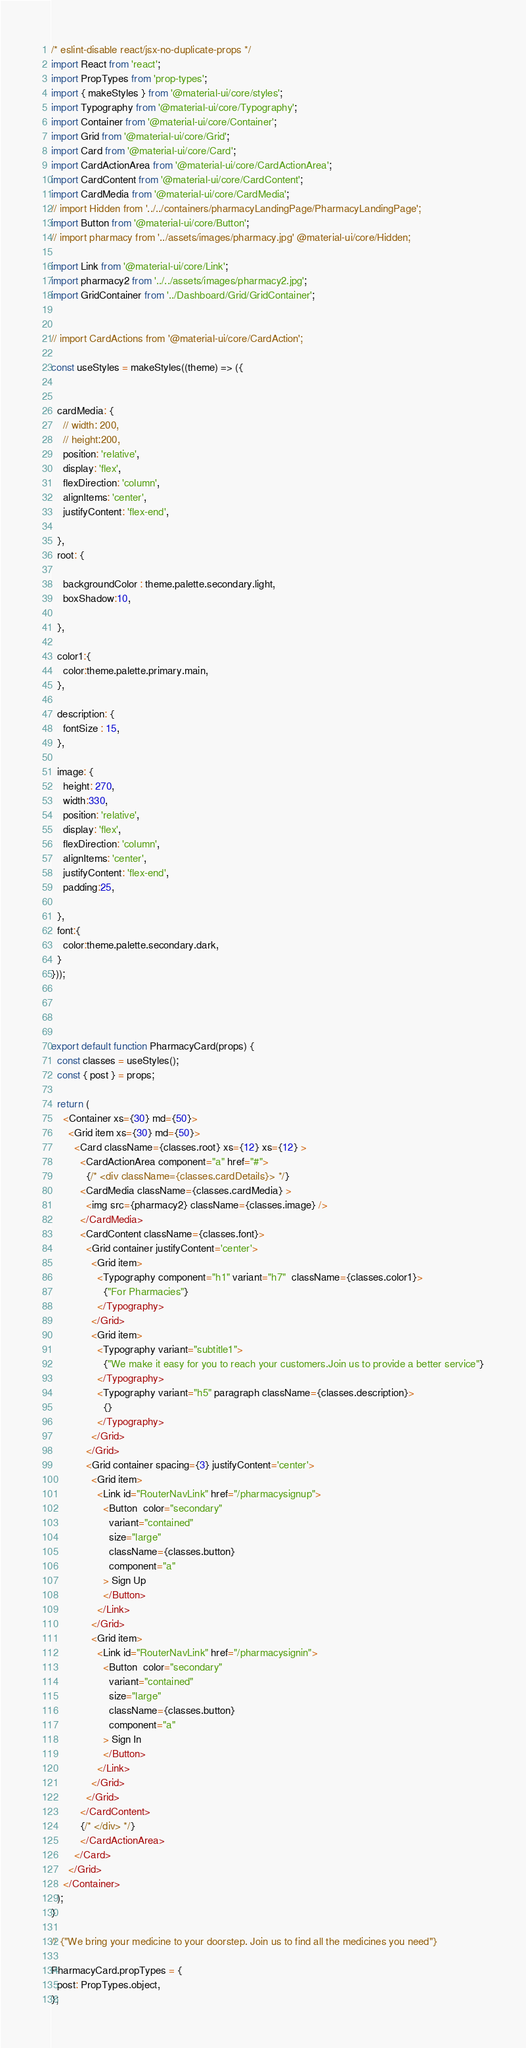Convert code to text. <code><loc_0><loc_0><loc_500><loc_500><_JavaScript_>/* eslint-disable react/jsx-no-duplicate-props */
import React from 'react';
import PropTypes from 'prop-types';
import { makeStyles } from '@material-ui/core/styles';
import Typography from '@material-ui/core/Typography';
import Container from '@material-ui/core/Container';
import Grid from '@material-ui/core/Grid';
import Card from '@material-ui/core/Card';
import CardActionArea from '@material-ui/core/CardActionArea';
import CardContent from '@material-ui/core/CardContent';
import CardMedia from '@material-ui/core/CardMedia';
// import Hidden from '../../containers/pharmacyLandingPage/PharmacyLandingPage';
import Button from '@material-ui/core/Button';  
// import pharmacy from '../assets/images/pharmacy.jpg' @material-ui/core/Hidden; 

import Link from '@material-ui/core/Link';
import pharmacy2 from '../../assets/images/pharmacy2.jpg';
import GridContainer from '../Dashboard/Grid/GridContainer';


// import CardActions from '@material-ui/core/CardAction';

const useStyles = makeStyles((theme) => ({
  
 
  cardMedia: {
    // width: 200,
    // height:200,
    position: 'relative',
    display: 'flex',
    flexDirection: 'column',
    alignItems: 'center',
    justifyContent: 'flex-end',
    
  },
  root: {
 
    backgroundColor : theme.palette.secondary.light,
    boxShadow:10,
 
  },

  color1:{
    color:theme.palette.primary.main,
  },

  description: {
    fontSize : 15,
  },

  image: {
    height: 270,
    width:330,
    position: 'relative',
    display: 'flex',
    flexDirection: 'column',
    alignItems: 'center',
    justifyContent: 'flex-end',
    padding:25,
    
  },
  font:{
    color:theme.palette.secondary.dark,
  }
}));




export default function PharmacyCard(props) {
  const classes = useStyles();
  const { post } = props;

  return (
    <Container xs={30} md={50}>
      <Grid item xs={30} md={50}>
        <Card className={classes.root} xs={12} xs={12} >
          <CardActionArea component="a" href="#">
            {/* <div className={classes.cardDetails}> */}
          <CardMedia className={classes.cardMedia} >
            <img src={pharmacy2} className={classes.image} />
          </CardMedia>
          <CardContent className={classes.font}>
            <Grid container justifyContent='center'>
              <Grid item>
                <Typography component="h1" variant="h7"  className={classes.color1}>
                  {"For Pharmacies"}
                </Typography>
              </Grid>
              <Grid item>
                <Typography variant="subtitle1">
                  {"We make it easy for you to reach your customers.Join us to provide a better service"}
                </Typography>
                <Typography variant="h5" paragraph className={classes.description}>
                  {}
                </Typography>
              </Grid>
            </Grid>
            <Grid container spacing={3} justifyContent='center'>
              <Grid item>
                <Link id="RouterNavLink" href="/pharmacysignup">                    
                  <Button  color="secondary"
                    variant="contained"
                    size="large"
                    className={classes.button}
                    component="a"
                  > Sign Up
                  </Button>
                </Link>
              </Grid>
              <Grid item>
                <Link id="RouterNavLink" href="/pharmacysignin">                    
                  <Button  color="secondary"
                    variant="contained"
                    size="large"
                    className={classes.button}
                    component="a"
                  > Sign In 
                  </Button>
                </Link>
              </Grid>
            </Grid>            
          </CardContent>
          {/* </div> */}
          </CardActionArea>
        </Card>
      </Grid>
    </Container>
  );
}

// {"We bring your medicine to your doorstep. Join us to find all the medicines you need"}

PharmacyCard.propTypes = {
  post: PropTypes.object,
};</code> 